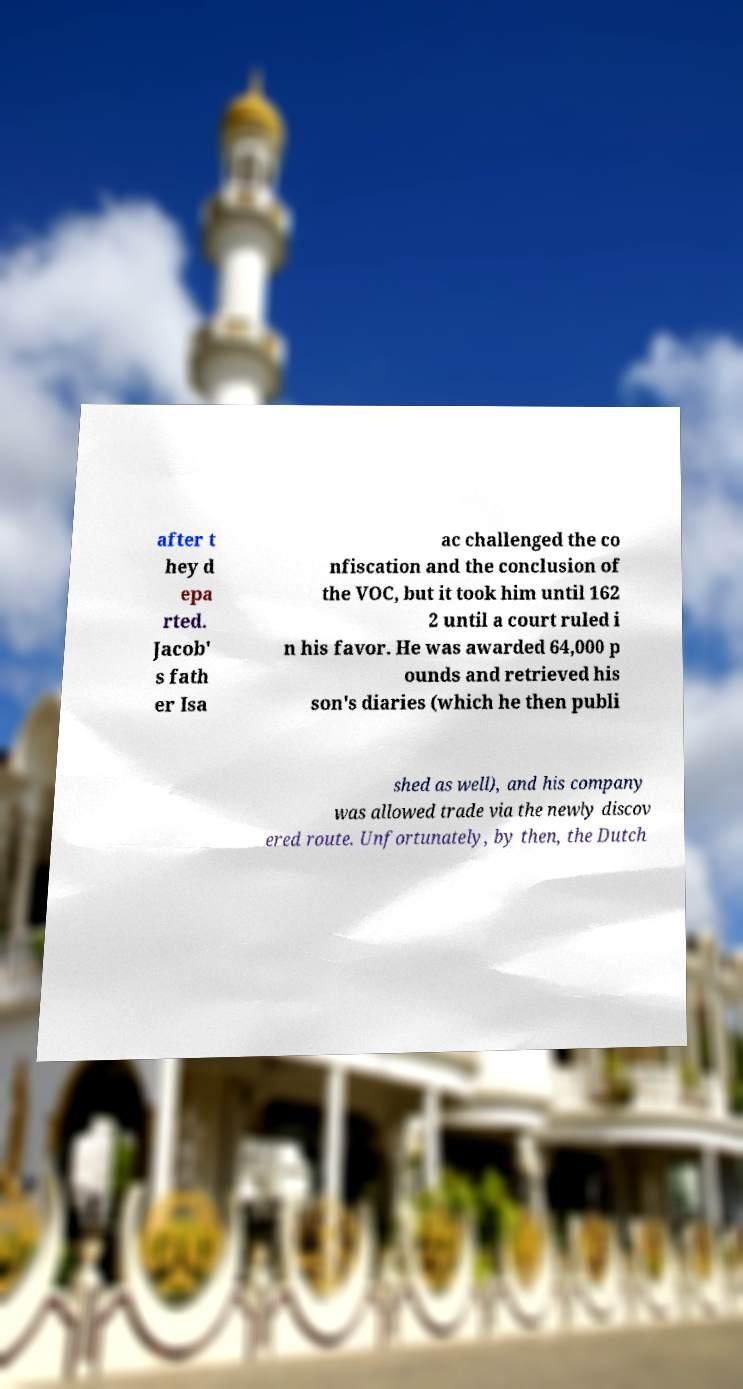I need the written content from this picture converted into text. Can you do that? after t hey d epa rted. Jacob' s fath er Isa ac challenged the co nfiscation and the conclusion of the VOC, but it took him until 162 2 until a court ruled i n his favor. He was awarded 64,000 p ounds and retrieved his son's diaries (which he then publi shed as well), and his company was allowed trade via the newly discov ered route. Unfortunately, by then, the Dutch 